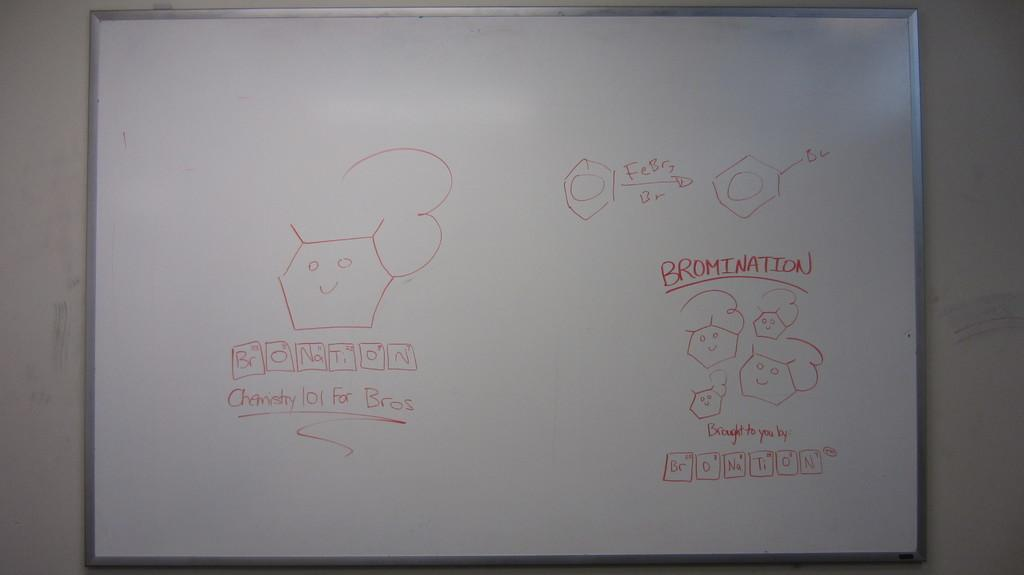Provide a one-sentence caption for the provided image. Someone has written Bromination on the whiteboard in red marker. 